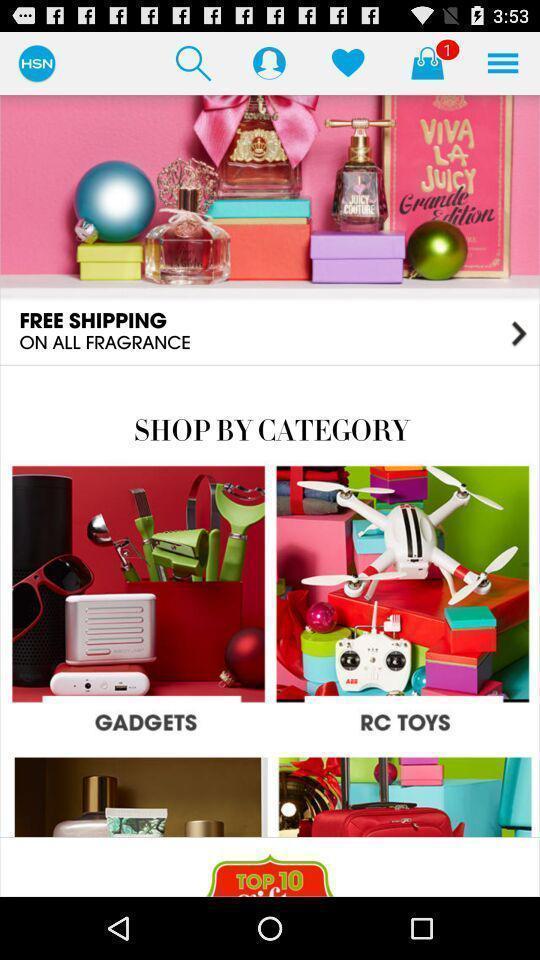Give me a summary of this screen capture. Screen shows multiple options in shopping app. 